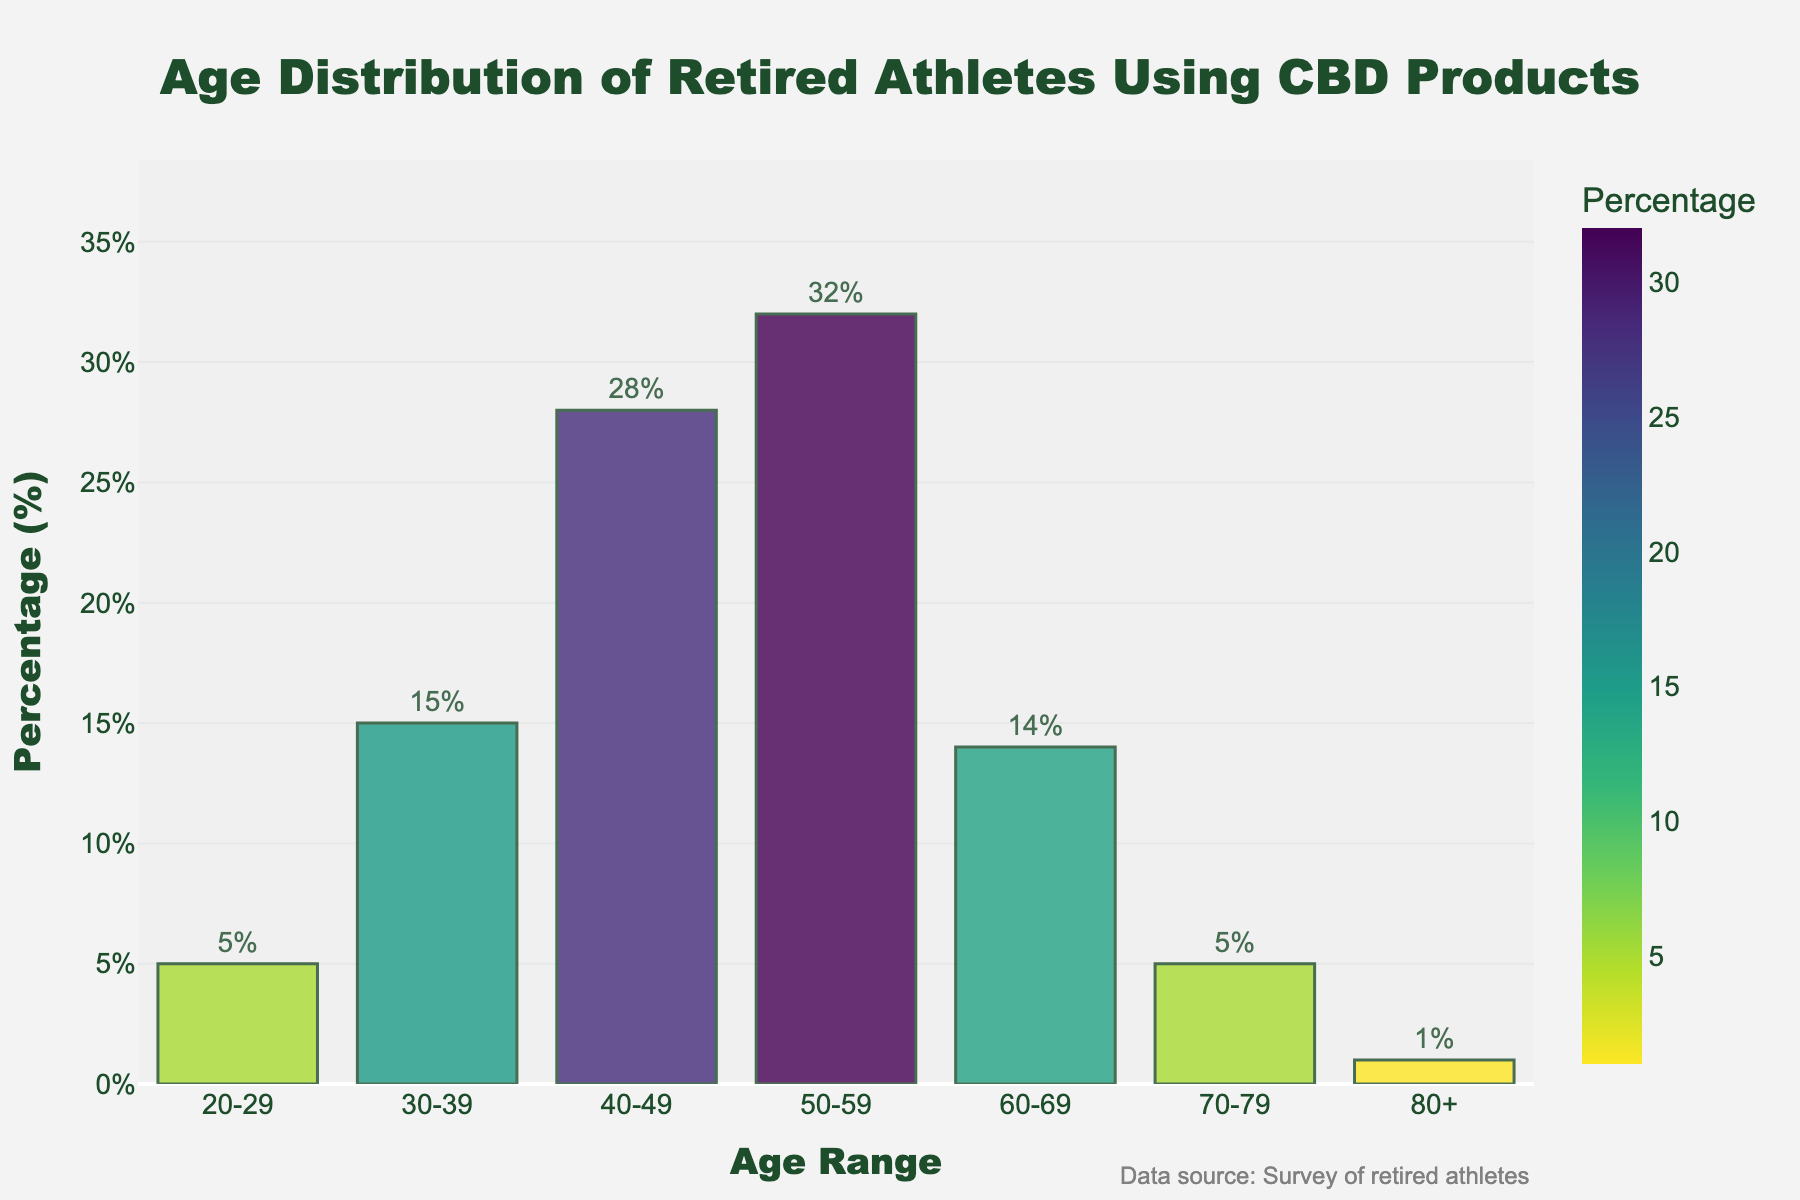Which age range has the highest percentage of retired athletes using CBD products? The age range 50-59 has the highest bar in the chart.
Answer: 50-59 How much more percentage do the 50-59 age range have over the 60-69 age range? The percentage for the 50-59 age range is 32%, and for 60-69 it is 14%. The difference is 32% - 14% = 18%.
Answer: 18% What is the combined percentage of retired athletes using CBD products in the 20-29 and 70-79 age ranges? The 20-29 age range has 5%, and the 70-79 age range also has 5%. So, combined percentage is 5% + 5% = 10%.
Answer: 10% Which age range has the lowest percentage of retired athletes using CBD products? The age range 80+ has the lowest percentage, represented by the smallest bar in the chart.
Answer: 80+ Is the percentage of retired athletes using CBD products in the 30-39 age range greater than in the 60-69 age range? The percentage for the 30-39 age range is 15%, and for the 60-69 age range, it is 14%. So, 15% is greater than 14%.
Answer: Yes What is the average percentage of retired athletes using CBD products in the 20-29, 70-79, and 80+ age ranges? The percentages are 5%, 5%, and 1% respectively. The average is (5% + 5% + 1%) / 3 = 3.67%.
Answer: 3.67% How do the percentages of the 40-49 and 50-59 age ranges compare to each other? The 40-49 age range has a percentage of 28%, and the 50-59 age range has a percentage of 32%. So, 32% is greater than 28%.
Answer: 50-59 is greater Between which adjacent age ranges does the largest percentage decrease occur? Comparing adjacent age ranges' percentages: 
20-29 (5%) to 30-39 (15%) = +10%, 
30-39 (15%) to 40-49 (28%) = +13%, 
40-49 (28%) to 50-59 (32%) = +4%, 
50-59 (32%) to 60-69 (14%) = -18%, 
60-69 (14%) to 70-79 (5%) = -9%, 
70-79 (5%) to 80+ (1%) = -4%.
The largest decrease is from 50-59 (32%) to 60-69 (14%), which is -18%.
Answer: 50-59 to 60-69 What is the median percentage value of all age ranges for retired athletes using CBD products? Organizing percentages in ascending order: 1%, 5%, 5%, 14%, 15%, 28%, 32%. The median value, or the middle point, is the fourth value: 14%.
Answer: 14% 